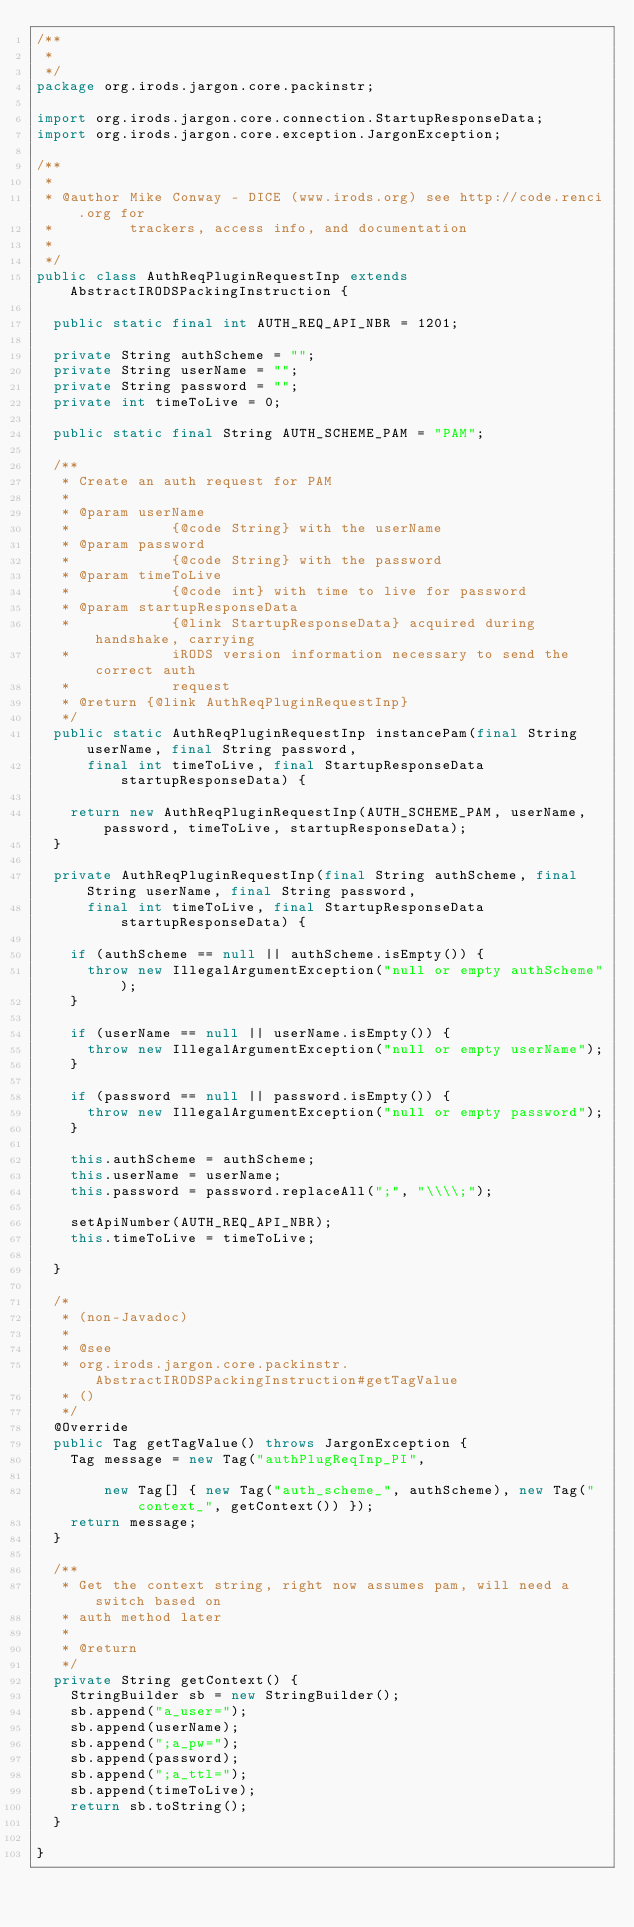Convert code to text. <code><loc_0><loc_0><loc_500><loc_500><_Java_>/**
 *
 */
package org.irods.jargon.core.packinstr;

import org.irods.jargon.core.connection.StartupResponseData;
import org.irods.jargon.core.exception.JargonException;

/**
 *
 * @author Mike Conway - DICE (www.irods.org) see http://code.renci.org for
 *         trackers, access info, and documentation
 *
 */
public class AuthReqPluginRequestInp extends AbstractIRODSPackingInstruction {

	public static final int AUTH_REQ_API_NBR = 1201;

	private String authScheme = "";
	private String userName = "";
	private String password = "";
	private int timeToLive = 0;

	public static final String AUTH_SCHEME_PAM = "PAM";

	/**
	 * Create an auth request for PAM
	 *
	 * @param userName
	 *            {@code String} with the userName
	 * @param password
	 *            {@code String} with the password
	 * @param timeToLive
	 *            {@code int} with time to live for password
	 * @param startupResponseData
	 *            {@link StartupResponseData} acquired during handshake, carrying
	 *            iRODS version information necessary to send the correct auth
	 *            request
	 * @return {@link AuthReqPluginRequestInp}
	 */
	public static AuthReqPluginRequestInp instancePam(final String userName, final String password,
			final int timeToLive, final StartupResponseData startupResponseData) {

		return new AuthReqPluginRequestInp(AUTH_SCHEME_PAM, userName, password, timeToLive, startupResponseData);
	}

	private AuthReqPluginRequestInp(final String authScheme, final String userName, final String password,
			final int timeToLive, final StartupResponseData startupResponseData) {

		if (authScheme == null || authScheme.isEmpty()) {
			throw new IllegalArgumentException("null or empty authScheme");
		}

		if (userName == null || userName.isEmpty()) {
			throw new IllegalArgumentException("null or empty userName");
		}

		if (password == null || password.isEmpty()) {
			throw new IllegalArgumentException("null or empty password");
		}

		this.authScheme = authScheme;
		this.userName = userName;
		this.password = password.replaceAll(";", "\\\\;");

		setApiNumber(AUTH_REQ_API_NBR);
		this.timeToLive = timeToLive;

	}

	/*
	 * (non-Javadoc)
	 *
	 * @see
	 * org.irods.jargon.core.packinstr.AbstractIRODSPackingInstruction#getTagValue
	 * ()
	 */
	@Override
	public Tag getTagValue() throws JargonException {
		Tag message = new Tag("authPlugReqInp_PI",

				new Tag[] { new Tag("auth_scheme_", authScheme), new Tag("context_", getContext()) });
		return message;
	}

	/**
	 * Get the context string, right now assumes pam, will need a switch based on
	 * auth method later
	 *
	 * @return
	 */
	private String getContext() {
		StringBuilder sb = new StringBuilder();
		sb.append("a_user=");
		sb.append(userName);
		sb.append(";a_pw=");
		sb.append(password);
		sb.append(";a_ttl=");
		sb.append(timeToLive);
		return sb.toString();
	}

}
</code> 